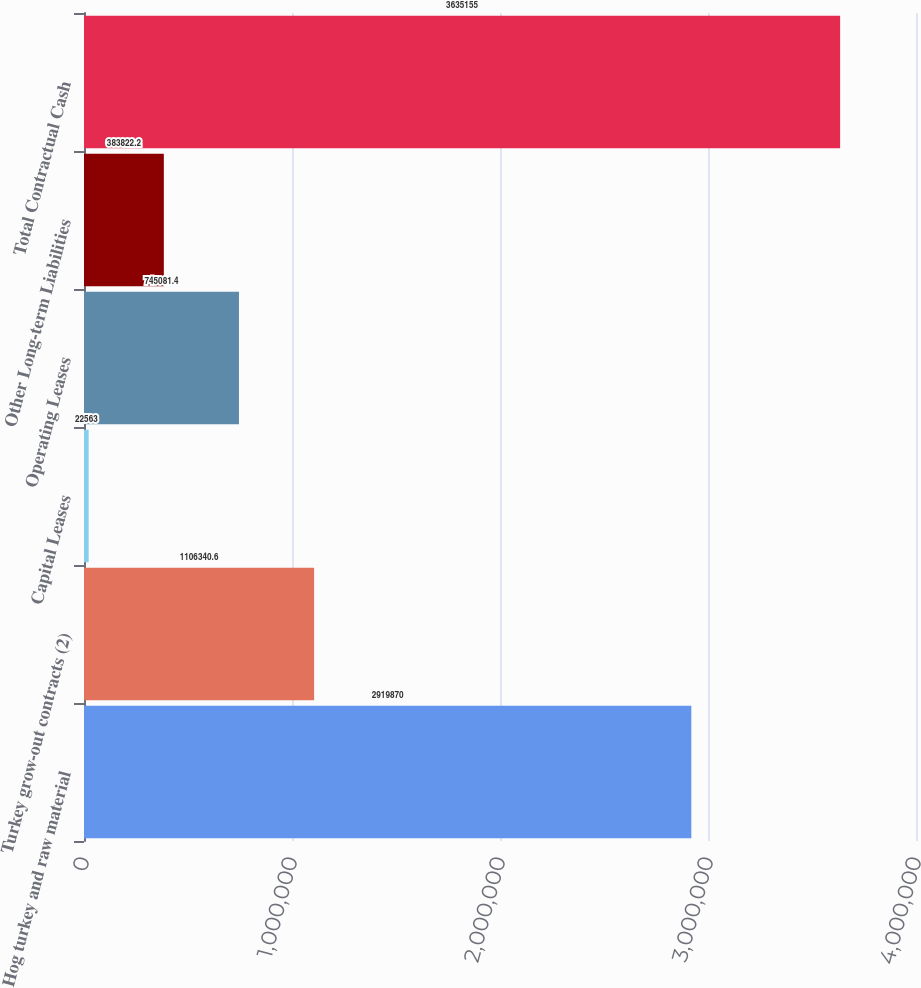Convert chart to OTSL. <chart><loc_0><loc_0><loc_500><loc_500><bar_chart><fcel>Hog turkey and raw material<fcel>Turkey grow-out contracts (2)<fcel>Capital Leases<fcel>Operating Leases<fcel>Other Long-term Liabilities<fcel>Total Contractual Cash<nl><fcel>2.91987e+06<fcel>1.10634e+06<fcel>22563<fcel>745081<fcel>383822<fcel>3.63516e+06<nl></chart> 